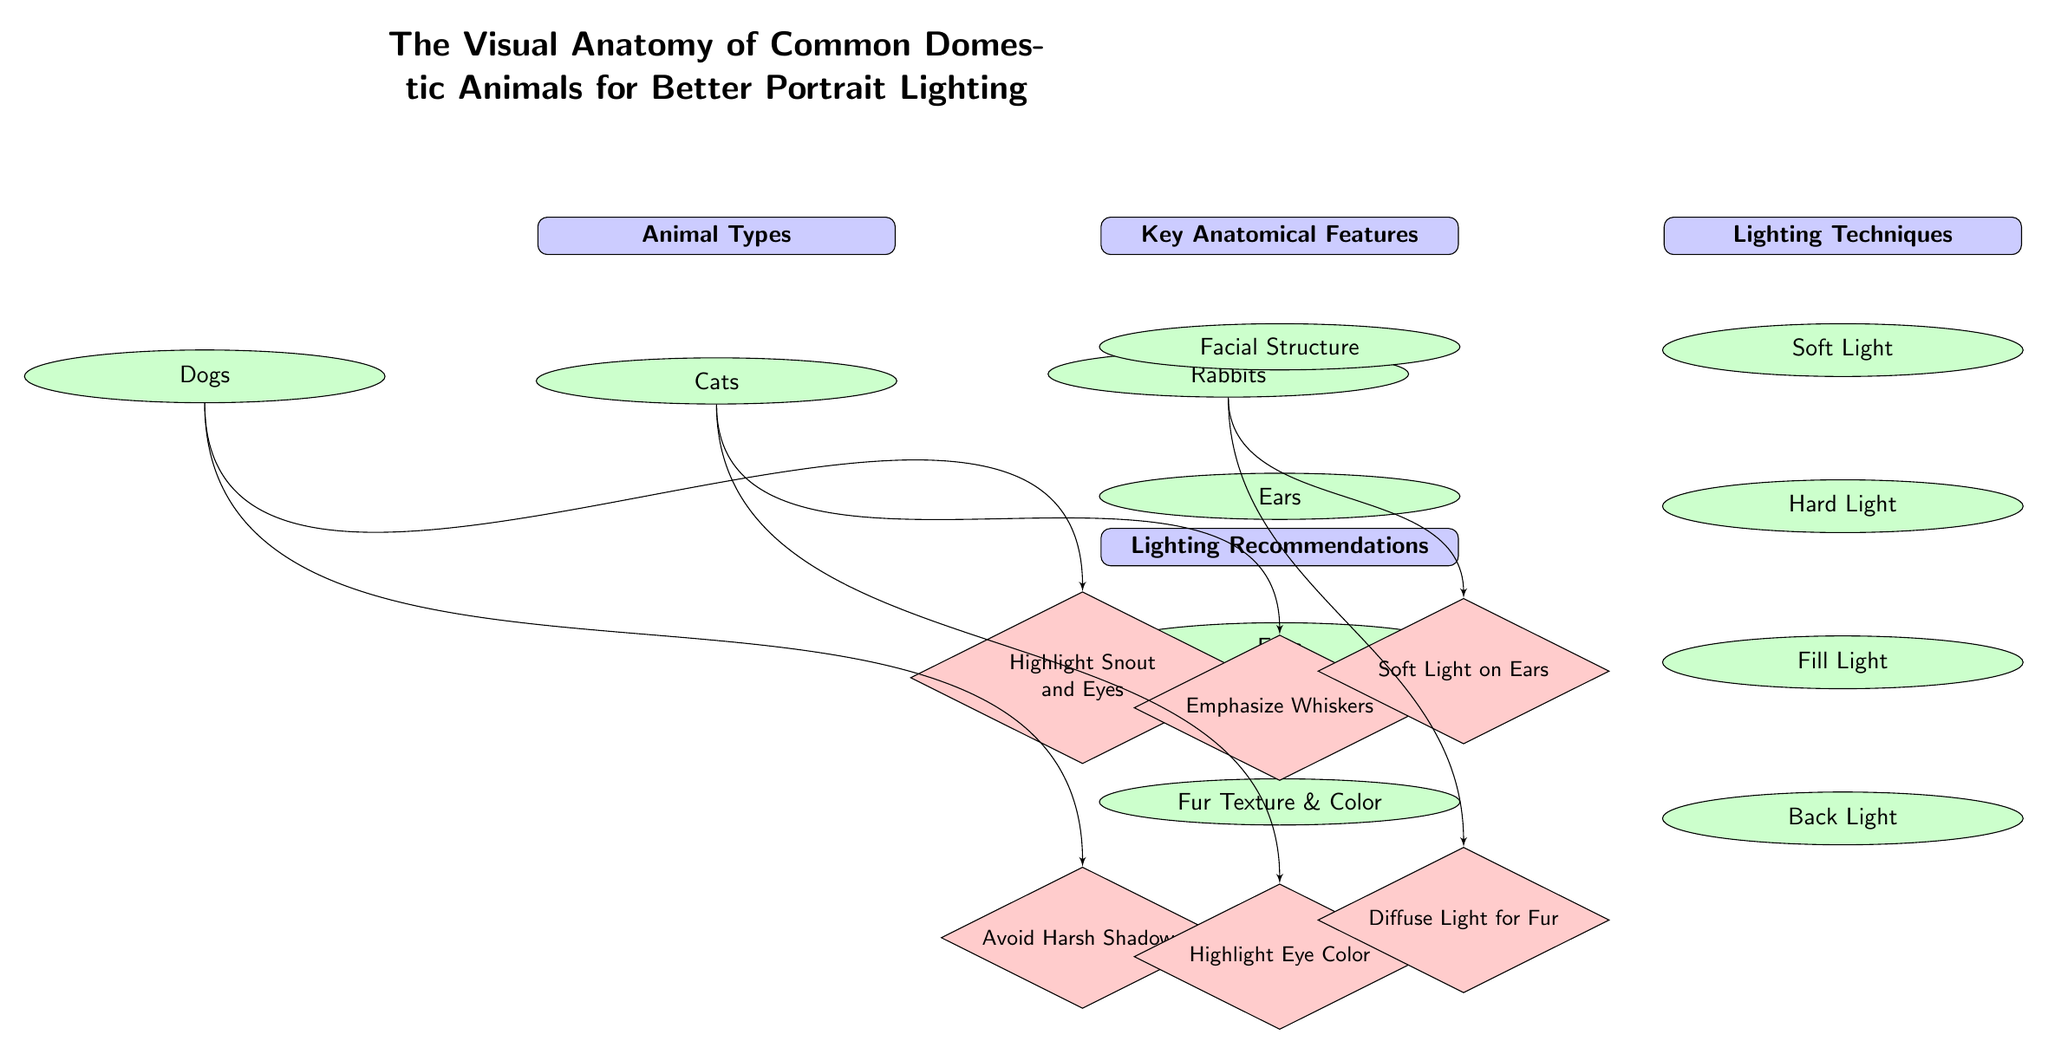What are the types of animals depicted in this diagram? The diagram lists three types of common domestic animals: Dogs, Cats, and Rabbits, which can be found below the "Animal Types" node.
Answer: Dogs, Cats, Rabbits How many key anatomical features are listed in the diagram? The diagram shows four key anatomical features: Facial Structure, Ears, Eyes, and Fur Texture & Color, which can be counted in the "Key Anatomical Features" section.
Answer: 4 Which lighting technique emphasizes whiskers in cat portraits? The diagram includes lighting recommendations for cats, specifically noting "Emphasize Whiskers" under the "Lighting Recommendations" section.
Answer: Emphasize Whiskers What is the lighting recommendation for rabbits to enhance fur texture? Under the "Lighting Recommendations" section, the diagram suggests "Diffuse Light for Fur," which specifically targets the fur texture of rabbits.
Answer: Diffuse Light for Fur What type of light is recommended to be avoided for dogs? The diagram advises to "Avoid Harsh Shadows" when lighting dogs, which is found in the specific recommendations for dog portraits.
Answer: Avoid Harsh Shadows How many lighting techniques are illustrated in the diagram? The diagram includes four lighting techniques: Soft Light, Hard Light, Fill Light, and Back Light, all listed under the "Lighting Techniques" section.
Answer: 4 Which anatomical feature is highlighted for both dogs and rabbits? The diagram highlights the anatomical feature "Eyes," which is suggested for both types under their respective recommendations.
Answer: Eyes What is the primary focus of soft light in pet photography according to the diagram? The diagram indicates that "Soft Light" is the first lighting technique listed, and it is generally used for a flattering presentation, crucial especially for capturing various animal features.
Answer: Soft Light 